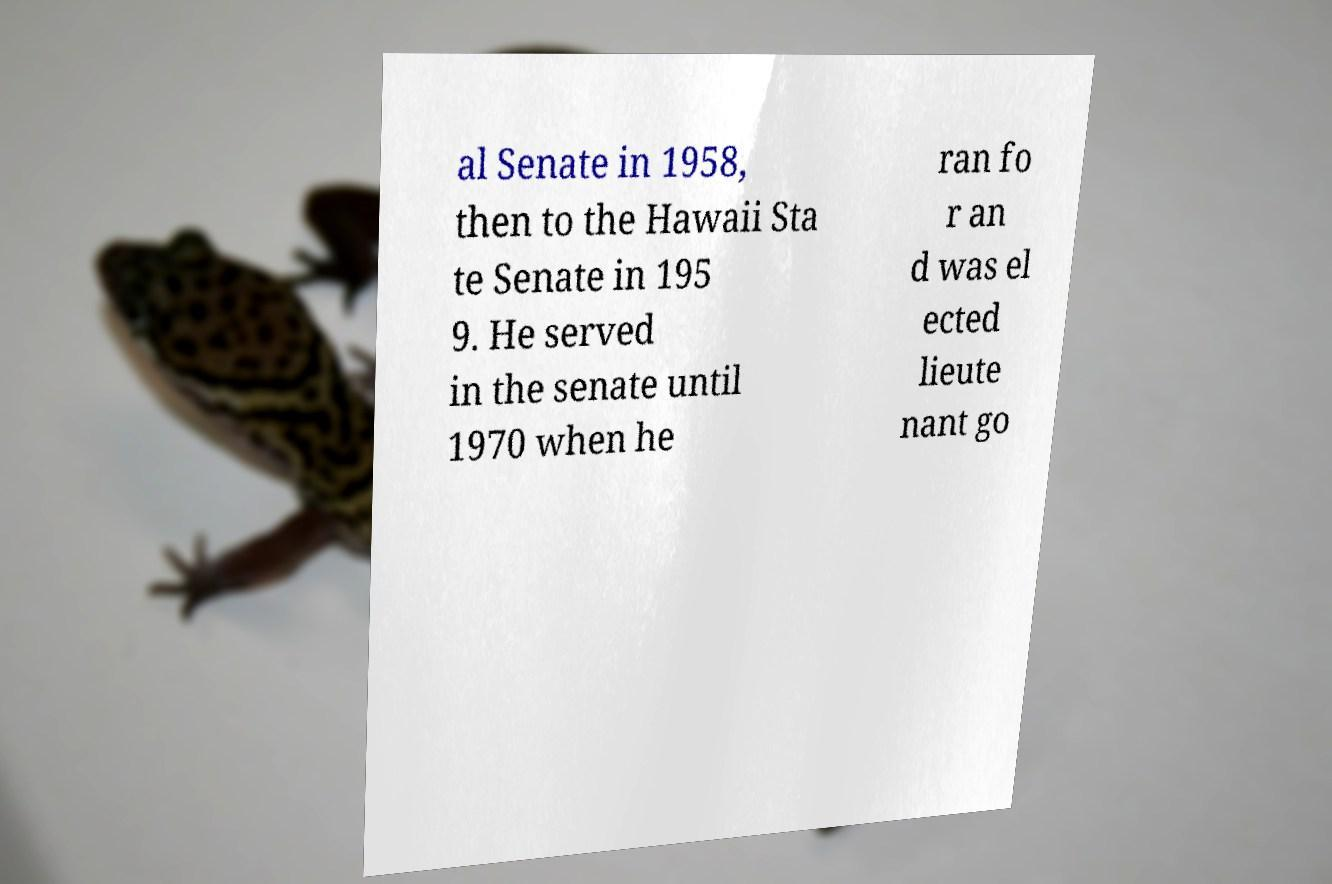I need the written content from this picture converted into text. Can you do that? al Senate in 1958, then to the Hawaii Sta te Senate in 195 9. He served in the senate until 1970 when he ran fo r an d was el ected lieute nant go 